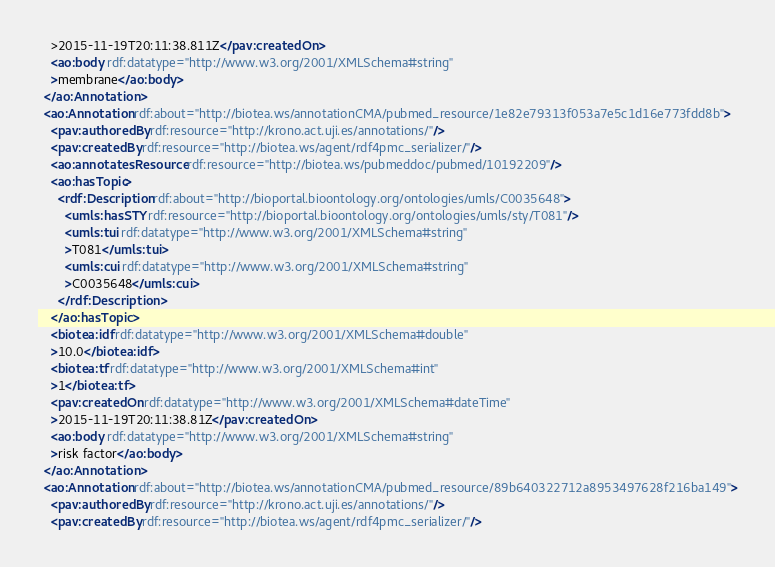<code> <loc_0><loc_0><loc_500><loc_500><_XML_>    >2015-11-19T20:11:38.811Z</pav:createdOn>
    <ao:body rdf:datatype="http://www.w3.org/2001/XMLSchema#string"
    >membrane</ao:body>
  </ao:Annotation>
  <ao:Annotation rdf:about="http://biotea.ws/annotationCMA/pubmed_resource/1e82e79313f053a7e5c1d16e773fdd8b">
    <pav:authoredBy rdf:resource="http://krono.act.uji.es/annotations/"/>
    <pav:createdBy rdf:resource="http://biotea.ws/agent/rdf4pmc_serializer/"/>
    <ao:annotatesResource rdf:resource="http://biotea.ws/pubmeddoc/pubmed/10192209"/>
    <ao:hasTopic>
      <rdf:Description rdf:about="http://bioportal.bioontology.org/ontologies/umls/C0035648">
        <umls:hasSTY rdf:resource="http://bioportal.bioontology.org/ontologies/umls/sty/T081"/>
        <umls:tui rdf:datatype="http://www.w3.org/2001/XMLSchema#string"
        >T081</umls:tui>
        <umls:cui rdf:datatype="http://www.w3.org/2001/XMLSchema#string"
        >C0035648</umls:cui>
      </rdf:Description>
    </ao:hasTopic>
    <biotea:idf rdf:datatype="http://www.w3.org/2001/XMLSchema#double"
    >10.0</biotea:idf>
    <biotea:tf rdf:datatype="http://www.w3.org/2001/XMLSchema#int"
    >1</biotea:tf>
    <pav:createdOn rdf:datatype="http://www.w3.org/2001/XMLSchema#dateTime"
    >2015-11-19T20:11:38.81Z</pav:createdOn>
    <ao:body rdf:datatype="http://www.w3.org/2001/XMLSchema#string"
    >risk factor</ao:body>
  </ao:Annotation>
  <ao:Annotation rdf:about="http://biotea.ws/annotationCMA/pubmed_resource/89b640322712a8953497628f216ba149">
    <pav:authoredBy rdf:resource="http://krono.act.uji.es/annotations/"/>
    <pav:createdBy rdf:resource="http://biotea.ws/agent/rdf4pmc_serializer/"/></code> 